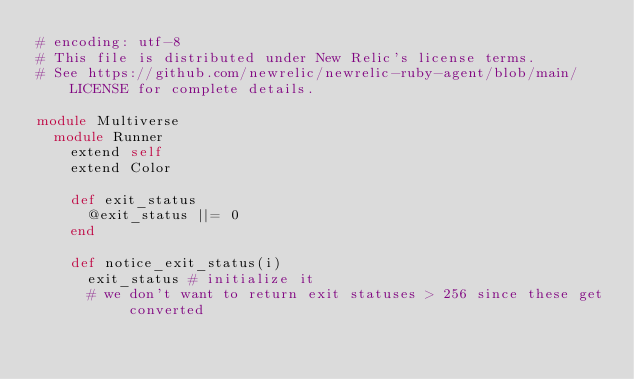Convert code to text. <code><loc_0><loc_0><loc_500><loc_500><_Ruby_># encoding: utf-8
# This file is distributed under New Relic's license terms.
# See https://github.com/newrelic/newrelic-ruby-agent/blob/main/LICENSE for complete details.

module Multiverse
  module Runner
    extend self
    extend Color

    def exit_status
      @exit_status ||= 0
    end

    def notice_exit_status(i)
      exit_status # initialize it
      # we don't want to return exit statuses > 256 since these get converted</code> 